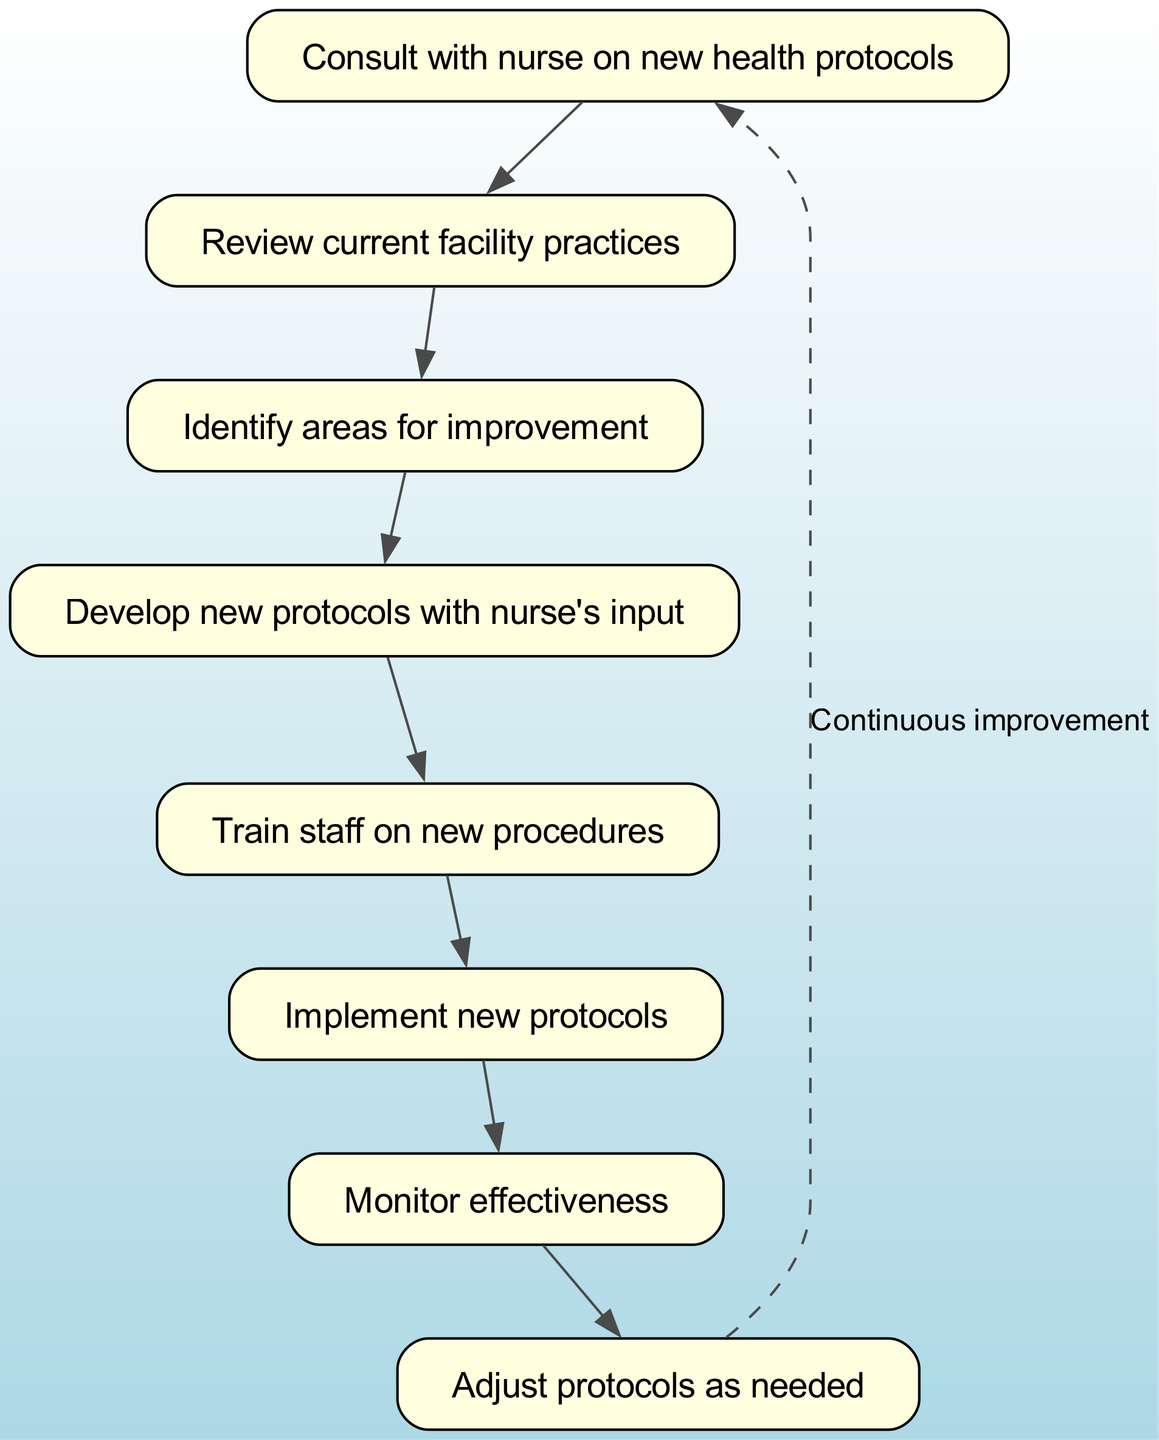What is the first step in the process? The first step identified in the diagram is "Consult with nurse on new health protocols," represented by the first node with ID 1.
Answer: Consult with nurse on new health protocols How many nodes are in the diagram? By counting all the distinct nodes listed in the data, we find there are 8 nodes that represent different steps in the process.
Answer: 8 What is the last step before adjusting protocols? The last step before adjusting protocols is "Monitor effectiveness," which is the seventh node in the flow.
Answer: Monitor effectiveness Which nodes are connected to the "Develop new protocols with nurse's input"? The node "Develop new protocols with nurse's input," which is node 4, is connected by an edge from node 3 ("Identify areas for improvement") and has an outgoing edge to node 5 ("Train staff on new procedures").
Answer: 3 and 5 How many edges are in the diagram? Counting the connections represented by the edges between nodes shows that there are 8 edges connecting the nodes in the flow chart.
Answer: 8 What is the relationship between "Implement new protocols" and "Monitor effectiveness"? The relationship is a direct sequential connection, where "Implement new protocols," node 6, is followed by "Monitor effectiveness," node 7, indicating that monitoring occurs after implementation.
Answer: Sequential connection What step follows the "Train staff on new procedures"? Following "Train staff on new procedures," which is node 5, the next step is "Implement new protocols," represented by node 6.
Answer: Implement new protocols How is "Adjust protocols as needed" related to the "Consult with nurse on new health protocols"? "Adjust protocols as needed," node 8, is related to the initial consulting step as it forms a continuous improvement loop, indicating that after adjustments, one should consult the nurse again for further health protocols.
Answer: Continuous improvement loop 